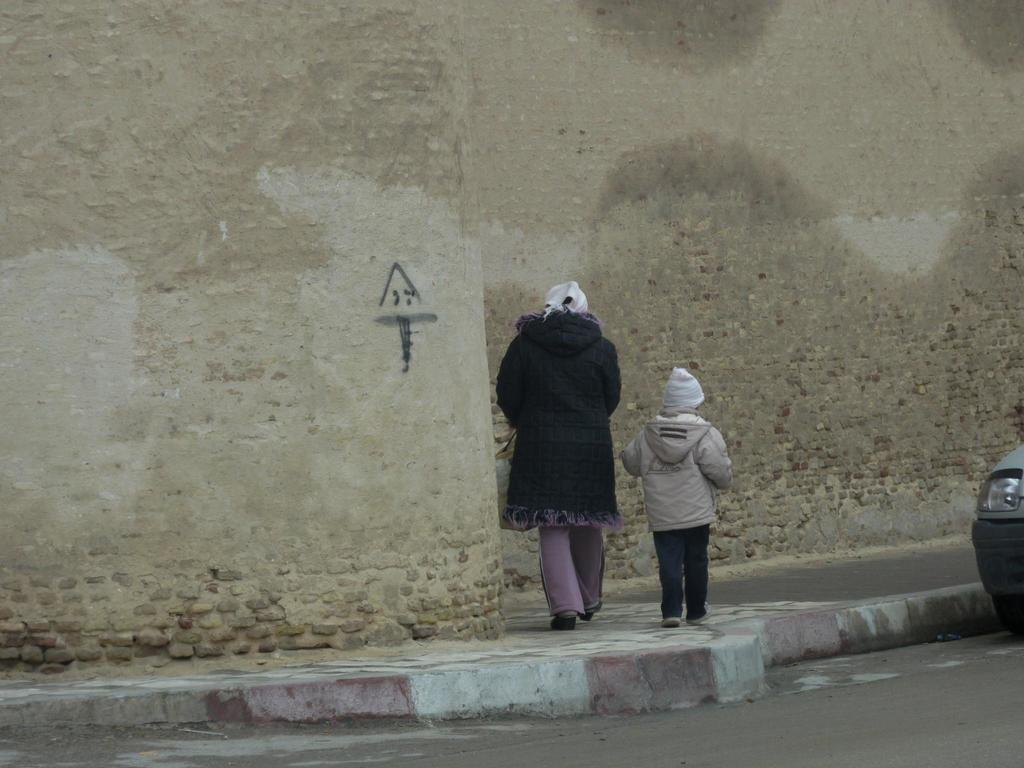How many people are walking in the image? There are two persons walking in the image. What surface are the persons walking on? The persons are walking on the pavement of a road. What else can be seen in the image besides the people walking? There is a vehicle in the image. What is visible in the background of the image? There is a wall in the background of the image. Can you tell me how many goldfish are swimming in the image? There are no goldfish present in the image; it features two people walking on a road. 